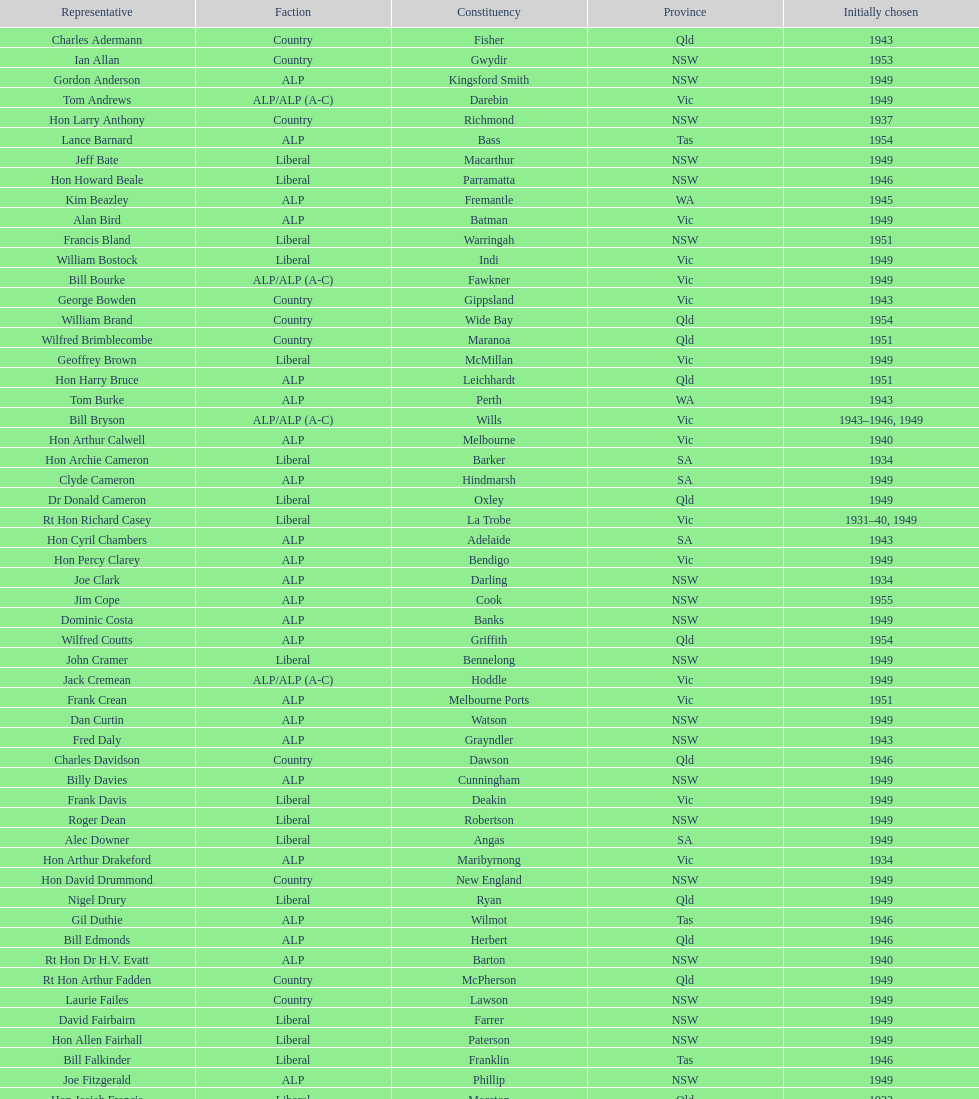Previous to tom andrews who was elected? Gordon Anderson. Would you mind parsing the complete table? {'header': ['Representative', 'Faction', 'Constituency', 'Province', 'Initially chosen'], 'rows': [['Charles Adermann', 'Country', 'Fisher', 'Qld', '1943'], ['Ian Allan', 'Country', 'Gwydir', 'NSW', '1953'], ['Gordon Anderson', 'ALP', 'Kingsford Smith', 'NSW', '1949'], ['Tom Andrews', 'ALP/ALP (A-C)', 'Darebin', 'Vic', '1949'], ['Hon Larry Anthony', 'Country', 'Richmond', 'NSW', '1937'], ['Lance Barnard', 'ALP', 'Bass', 'Tas', '1954'], ['Jeff Bate', 'Liberal', 'Macarthur', 'NSW', '1949'], ['Hon Howard Beale', 'Liberal', 'Parramatta', 'NSW', '1946'], ['Kim Beazley', 'ALP', 'Fremantle', 'WA', '1945'], ['Alan Bird', 'ALP', 'Batman', 'Vic', '1949'], ['Francis Bland', 'Liberal', 'Warringah', 'NSW', '1951'], ['William Bostock', 'Liberal', 'Indi', 'Vic', '1949'], ['Bill Bourke', 'ALP/ALP (A-C)', 'Fawkner', 'Vic', '1949'], ['George Bowden', 'Country', 'Gippsland', 'Vic', '1943'], ['William Brand', 'Country', 'Wide Bay', 'Qld', '1954'], ['Wilfred Brimblecombe', 'Country', 'Maranoa', 'Qld', '1951'], ['Geoffrey Brown', 'Liberal', 'McMillan', 'Vic', '1949'], ['Hon Harry Bruce', 'ALP', 'Leichhardt', 'Qld', '1951'], ['Tom Burke', 'ALP', 'Perth', 'WA', '1943'], ['Bill Bryson', 'ALP/ALP (A-C)', 'Wills', 'Vic', '1943–1946, 1949'], ['Hon Arthur Calwell', 'ALP', 'Melbourne', 'Vic', '1940'], ['Hon Archie Cameron', 'Liberal', 'Barker', 'SA', '1934'], ['Clyde Cameron', 'ALP', 'Hindmarsh', 'SA', '1949'], ['Dr Donald Cameron', 'Liberal', 'Oxley', 'Qld', '1949'], ['Rt Hon Richard Casey', 'Liberal', 'La Trobe', 'Vic', '1931–40, 1949'], ['Hon Cyril Chambers', 'ALP', 'Adelaide', 'SA', '1943'], ['Hon Percy Clarey', 'ALP', 'Bendigo', 'Vic', '1949'], ['Joe Clark', 'ALP', 'Darling', 'NSW', '1934'], ['Jim Cope', 'ALP', 'Cook', 'NSW', '1955'], ['Dominic Costa', 'ALP', 'Banks', 'NSW', '1949'], ['Wilfred Coutts', 'ALP', 'Griffith', 'Qld', '1954'], ['John Cramer', 'Liberal', 'Bennelong', 'NSW', '1949'], ['Jack Cremean', 'ALP/ALP (A-C)', 'Hoddle', 'Vic', '1949'], ['Frank Crean', 'ALP', 'Melbourne Ports', 'Vic', '1951'], ['Dan Curtin', 'ALP', 'Watson', 'NSW', '1949'], ['Fred Daly', 'ALP', 'Grayndler', 'NSW', '1943'], ['Charles Davidson', 'Country', 'Dawson', 'Qld', '1946'], ['Billy Davies', 'ALP', 'Cunningham', 'NSW', '1949'], ['Frank Davis', 'Liberal', 'Deakin', 'Vic', '1949'], ['Roger Dean', 'Liberal', 'Robertson', 'NSW', '1949'], ['Alec Downer', 'Liberal', 'Angas', 'SA', '1949'], ['Hon Arthur Drakeford', 'ALP', 'Maribyrnong', 'Vic', '1934'], ['Hon David Drummond', 'Country', 'New England', 'NSW', '1949'], ['Nigel Drury', 'Liberal', 'Ryan', 'Qld', '1949'], ['Gil Duthie', 'ALP', 'Wilmot', 'Tas', '1946'], ['Bill Edmonds', 'ALP', 'Herbert', 'Qld', '1946'], ['Rt Hon Dr H.V. Evatt', 'ALP', 'Barton', 'NSW', '1940'], ['Rt Hon Arthur Fadden', 'Country', 'McPherson', 'Qld', '1949'], ['Laurie Failes', 'Country', 'Lawson', 'NSW', '1949'], ['David Fairbairn', 'Liberal', 'Farrer', 'NSW', '1949'], ['Hon Allen Fairhall', 'Liberal', 'Paterson', 'NSW', '1949'], ['Bill Falkinder', 'Liberal', 'Franklin', 'Tas', '1946'], ['Joe Fitzgerald', 'ALP', 'Phillip', 'NSW', '1949'], ['Hon Josiah Francis', 'Liberal', 'Moreton', 'Qld', '1922'], ['Allan Fraser', 'ALP', 'Eden-Monaro', 'NSW', '1943'], ['Jim Fraser', 'ALP', 'Australian Capital Territory', 'ACT', '1951'], ['Gordon Freeth', 'Liberal', 'Forrest', 'WA', '1949'], ['Arthur Fuller', 'Country', 'Hume', 'NSW', '1943–49, 1951'], ['Pat Galvin', 'ALP', 'Kingston', 'SA', '1951'], ['Arthur Greenup', 'ALP', 'Dalley', 'NSW', '1953'], ['Charles Griffiths', 'ALP', 'Shortland', 'NSW', '1949'], ['Jo Gullett', 'Liberal', 'Henty', 'Vic', '1946'], ['Len Hamilton', 'Country', 'Canning', 'WA', '1946'], ['Rt Hon Eric Harrison', 'Liberal', 'Wentworth', 'NSW', '1931'], ['Jim Harrison', 'ALP', 'Blaxland', 'NSW', '1949'], ['Hon Paul Hasluck', 'Liberal', 'Curtin', 'WA', '1949'], ['Hon William Haworth', 'Liberal', 'Isaacs', 'Vic', '1949'], ['Leslie Haylen', 'ALP', 'Parkes', 'NSW', '1943'], ['Rt Hon Harold Holt', 'Liberal', 'Higgins', 'Vic', '1935'], ['John Howse', 'Liberal', 'Calare', 'NSW', '1946'], ['Alan Hulme', 'Liberal', 'Petrie', 'Qld', '1949'], ['William Jack', 'Liberal', 'North Sydney', 'NSW', '1949'], ['Rowley James', 'ALP', 'Hunter', 'NSW', '1928'], ['Hon Herbert Johnson', 'ALP', 'Kalgoorlie', 'WA', '1940'], ['Bob Joshua', 'ALP/ALP (A-C)', 'Ballaarat', 'ALP', '1951'], ['Percy Joske', 'Liberal', 'Balaclava', 'Vic', '1951'], ['Hon Wilfrid Kent Hughes', 'Liberal', 'Chisholm', 'Vic', '1949'], ['Stan Keon', 'ALP/ALP (A-C)', 'Yarra', 'Vic', '1949'], ['William Lawrence', 'Liberal', 'Wimmera', 'Vic', '1949'], ['Hon George Lawson', 'ALP', 'Brisbane', 'Qld', '1931'], ['Nelson Lemmon', 'ALP', 'St George', 'NSW', '1943–49, 1954'], ['Hugh Leslie', 'Liberal', 'Moore', 'Country', '1949'], ['Robert Lindsay', 'Liberal', 'Flinders', 'Vic', '1954'], ['Tony Luchetti', 'ALP', 'Macquarie', 'NSW', '1951'], ['Aubrey Luck', 'Liberal', 'Darwin', 'Tas', '1951'], ['Philip Lucock', 'Country', 'Lyne', 'NSW', '1953'], ['Dan Mackinnon', 'Liberal', 'Corangamite', 'Vic', '1949–51, 1953'], ['Hon Norman Makin', 'ALP', 'Sturt', 'SA', '1919–46, 1954'], ['Hon Philip McBride', 'Liberal', 'Wakefield', 'SA', '1931–37, 1937–43 (S), 1946'], ['Malcolm McColm', 'Liberal', 'Bowman', 'Qld', '1949'], ['Rt Hon John McEwen', 'Country', 'Murray', 'Vic', '1934'], ['John McLeay', 'Liberal', 'Boothby', 'SA', '1949'], ['Don McLeod', 'Liberal', 'Wannon', 'ALP', '1940–49, 1951'], ['Hon William McMahon', 'Liberal', 'Lowe', 'NSW', '1949'], ['Rt Hon Robert Menzies', 'Liberal', 'Kooyong', 'Vic', '1934'], ['Dan Minogue', 'ALP', 'West Sydney', 'NSW', '1949'], ['Charles Morgan', 'ALP', 'Reid', 'NSW', '1940–46, 1949'], ['Jack Mullens', 'ALP/ALP (A-C)', 'Gellibrand', 'Vic', '1949'], ['Jock Nelson', 'ALP', 'Northern Territory', 'NT', '1949'], ["William O'Connor", 'ALP', 'Martin', 'NSW', '1946'], ['Hubert Opperman', 'Liberal', 'Corio', 'Vic', '1949'], ['Hon Frederick Osborne', 'Liberal', 'Evans', 'NSW', '1949'], ['Rt Hon Sir Earle Page', 'Country', 'Cowper', 'NSW', '1919'], ['Henry Pearce', 'Liberal', 'Capricornia', 'Qld', '1949'], ['Ted Peters', 'ALP', 'Burke', 'Vic', '1949'], ['Hon Reg Pollard', 'ALP', 'Lalor', 'Vic', '1937'], ['Hon Bill Riordan', 'ALP', 'Kennedy', 'Qld', '1936'], ['Hugh Roberton', 'Country', 'Riverina', 'NSW', '1949'], ['Edgar Russell', 'ALP', 'Grey', 'SA', '1943'], ['Tom Sheehan', 'ALP', 'Cook', 'NSW', '1937'], ['Frank Stewart', 'ALP', 'Lang', 'NSW', '1953'], ['Reginald Swartz', 'Liberal', 'Darling Downs', 'Qld', '1949'], ['Albert Thompson', 'ALP', 'Port Adelaide', 'SA', '1946'], ['Frank Timson', 'Liberal', 'Higinbotham', 'Vic', '1949'], ['Hon Athol Townley', 'Liberal', 'Denison', 'Tas', '1949'], ['Winton Turnbull', 'Country', 'Mallee', 'Vic', '1946'], ['Harry Turner', 'Liberal', 'Bradfield', 'NSW', '1952'], ['Hon Eddie Ward', 'ALP', 'East Sydney', 'NSW', '1931, 1932'], ['David Oliver Watkins', 'ALP', 'Newcastle', 'NSW', '1935'], ['Harry Webb', 'ALP', 'Swan', 'WA', '1954'], ['William Wentworth', 'Liberal', 'Mackellar', 'NSW', '1949'], ['Roy Wheeler', 'Liberal', 'Mitchell', 'NSW', '1949'], ['Gough Whitlam', 'ALP', 'Werriwa', 'NSW', '1952'], ['Bruce Wight', 'Liberal', 'Lilley', 'Qld', '1949']]} 